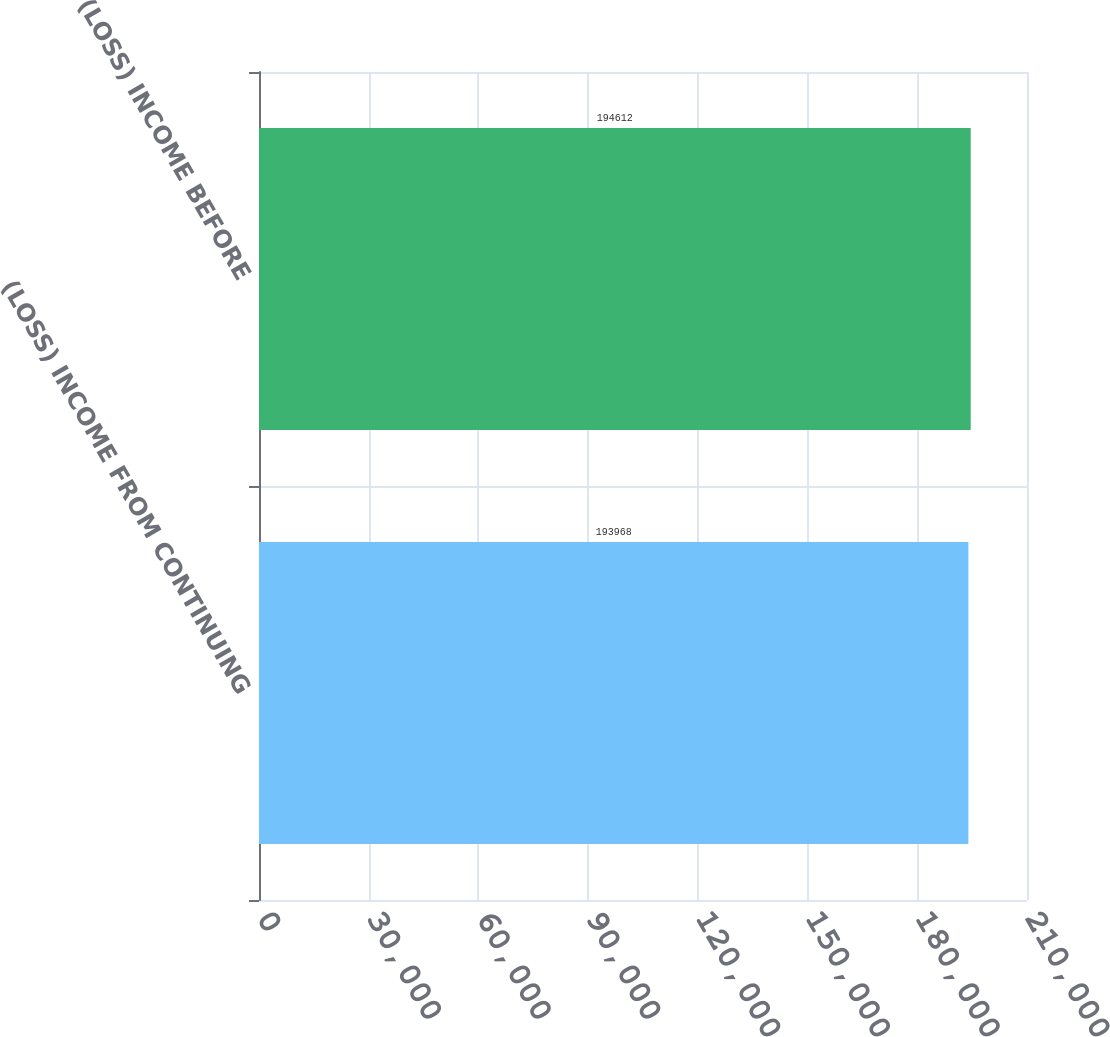Convert chart. <chart><loc_0><loc_0><loc_500><loc_500><bar_chart><fcel>(LOSS) INCOME FROM CONTINUING<fcel>(LOSS) INCOME BEFORE<nl><fcel>193968<fcel>194612<nl></chart> 